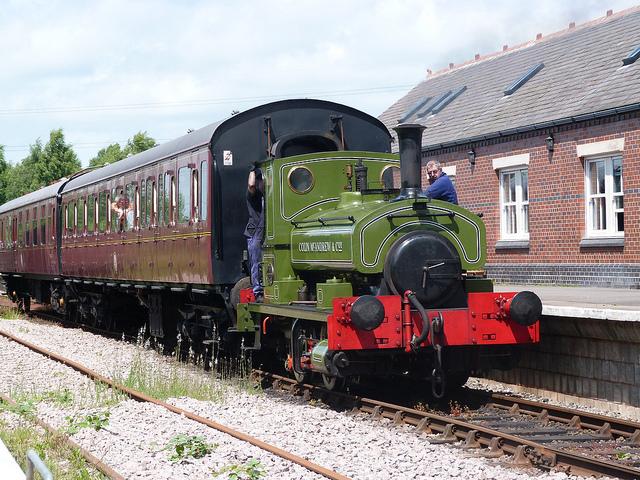How many men are hanging onto it?
Write a very short answer. 2. What color is the engine?
Short answer required. Green. Is this a cargo train?
Quick response, please. No. 